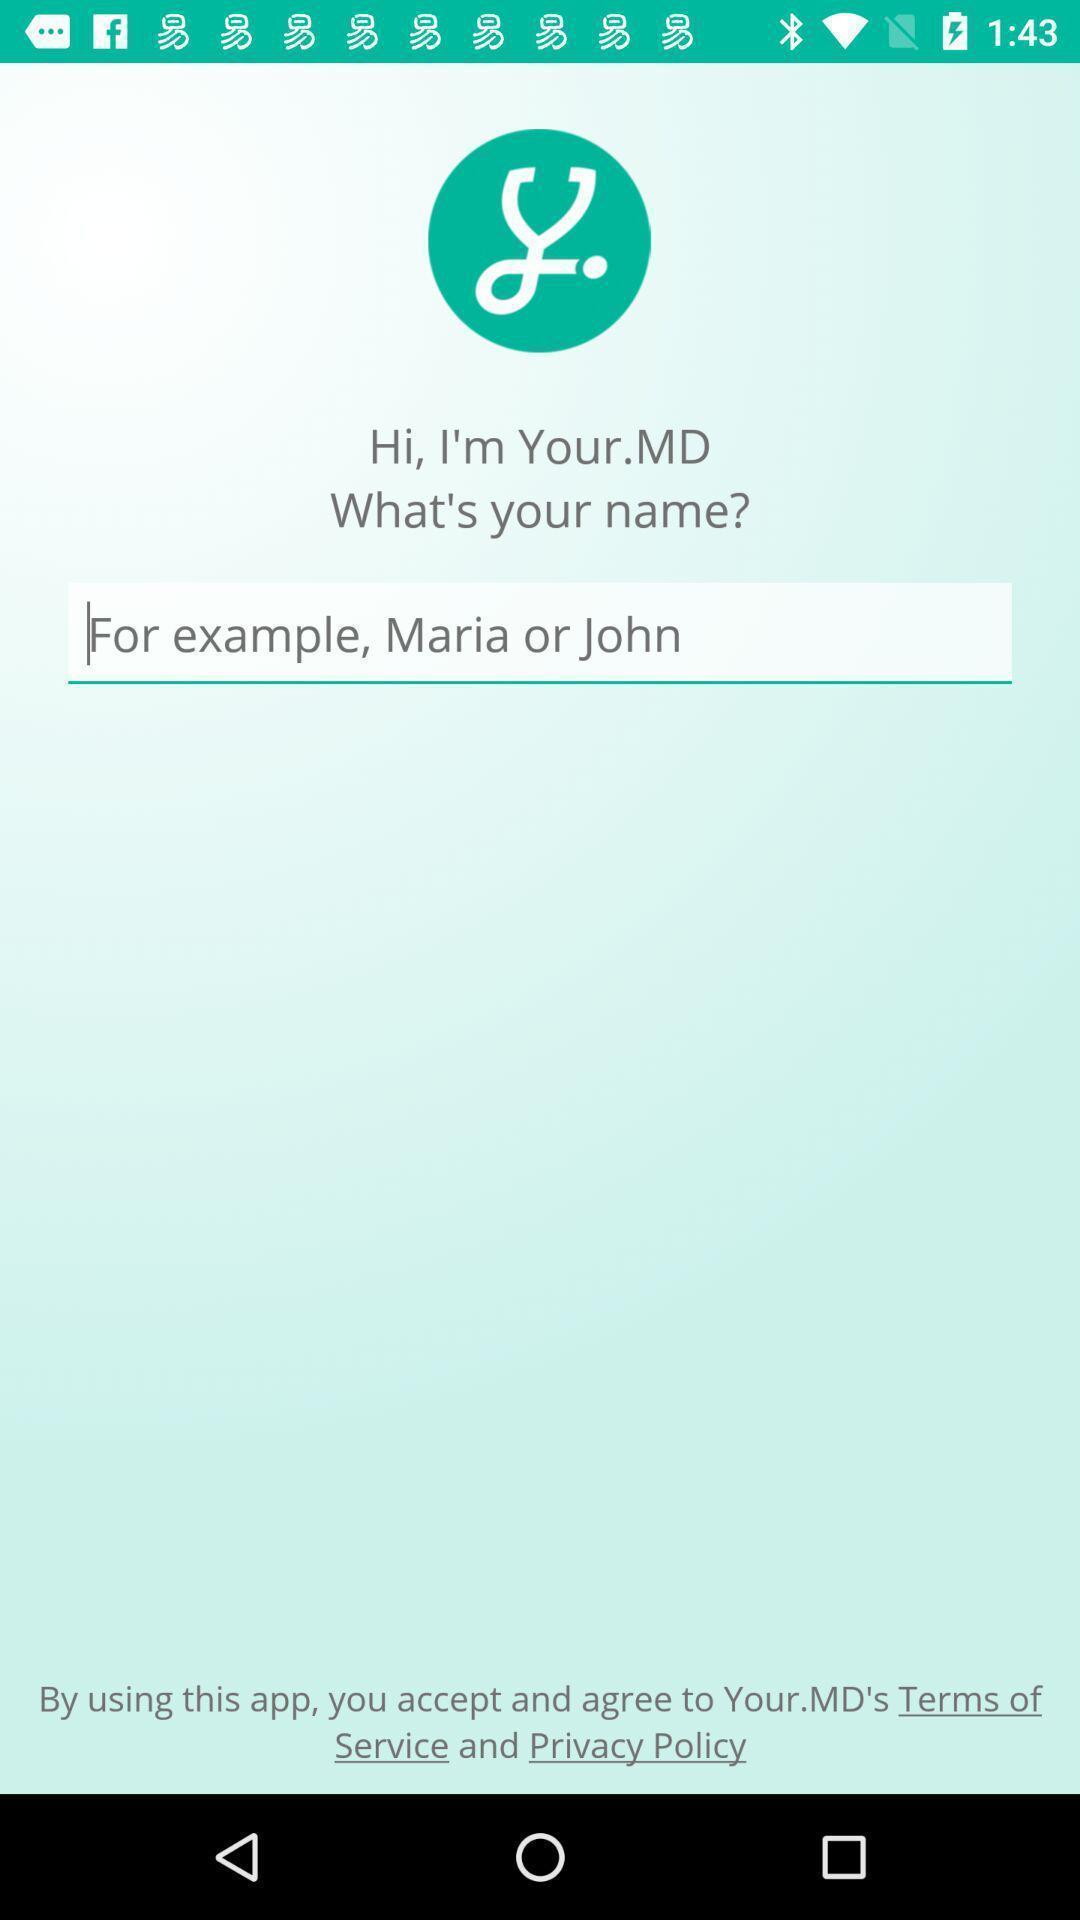What details can you identify in this image? Page showing option to add name. 